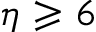Convert formula to latex. <formula><loc_0><loc_0><loc_500><loc_500>\eta \geqslant 6</formula> 